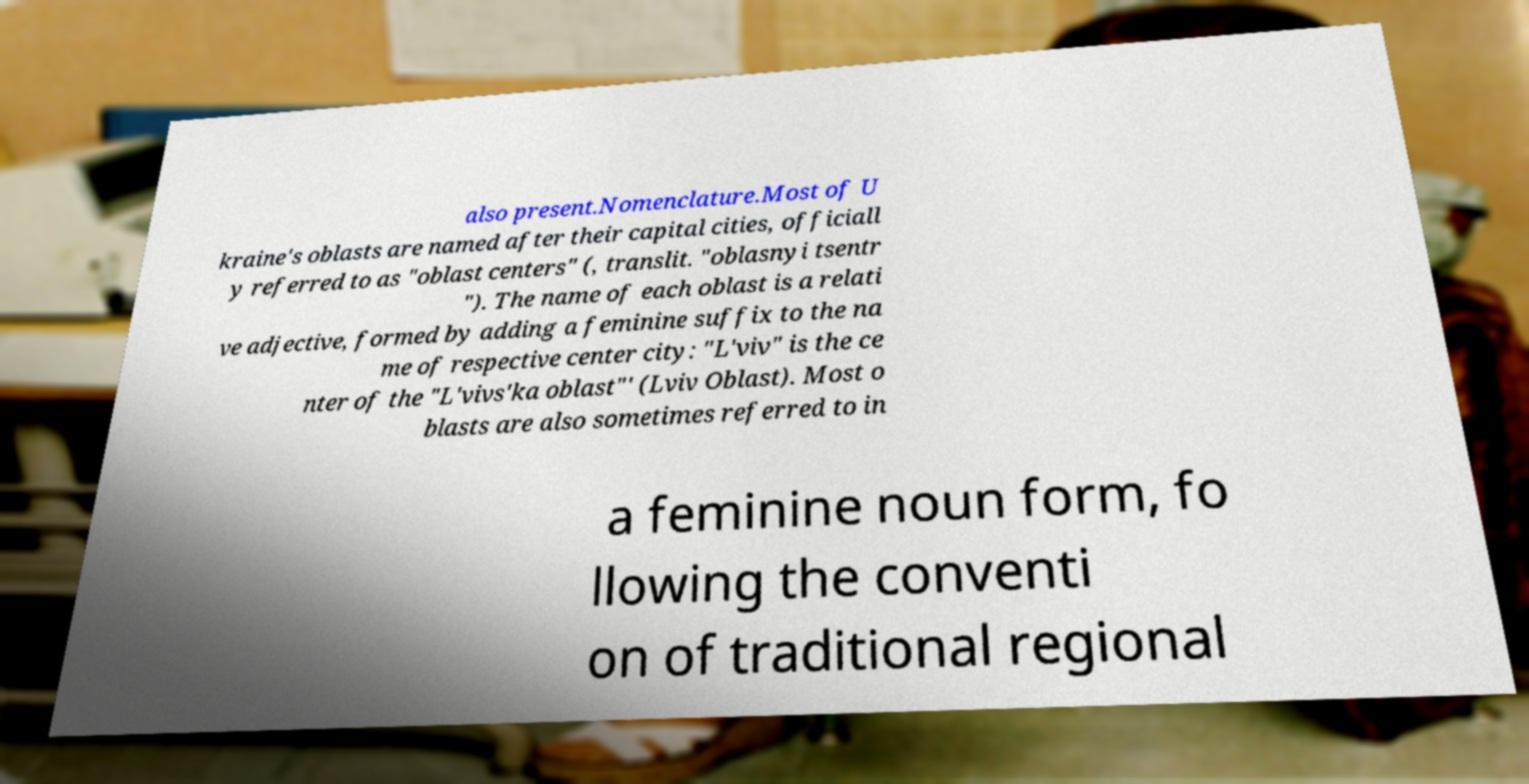Could you extract and type out the text from this image? also present.Nomenclature.Most of U kraine's oblasts are named after their capital cities, officiall y referred to as "oblast centers" (, translit. "oblasnyi tsentr "). The name of each oblast is a relati ve adjective, formed by adding a feminine suffix to the na me of respective center city: "L'viv" is the ce nter of the "L'vivs'ka oblast"' (Lviv Oblast). Most o blasts are also sometimes referred to in a feminine noun form, fo llowing the conventi on of traditional regional 